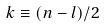<formula> <loc_0><loc_0><loc_500><loc_500>k \equiv ( n - l ) / 2</formula> 